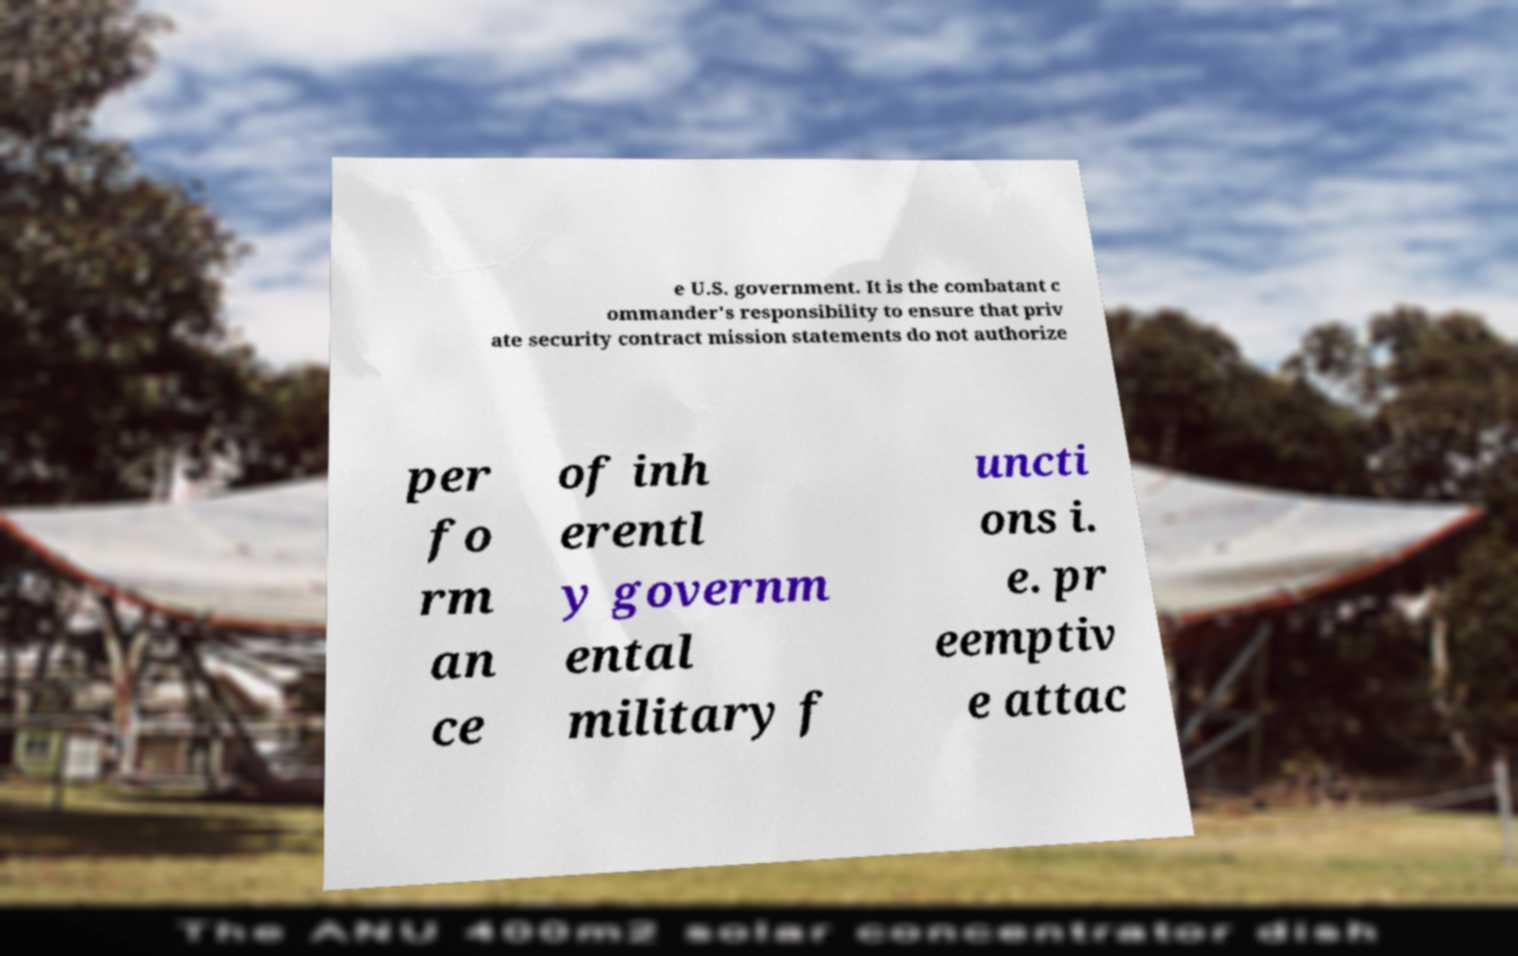Can you accurately transcribe the text from the provided image for me? e U.S. government. It is the combatant c ommander's responsibility to ensure that priv ate security contract mission statements do not authorize per fo rm an ce of inh erentl y governm ental military f uncti ons i. e. pr eemptiv e attac 